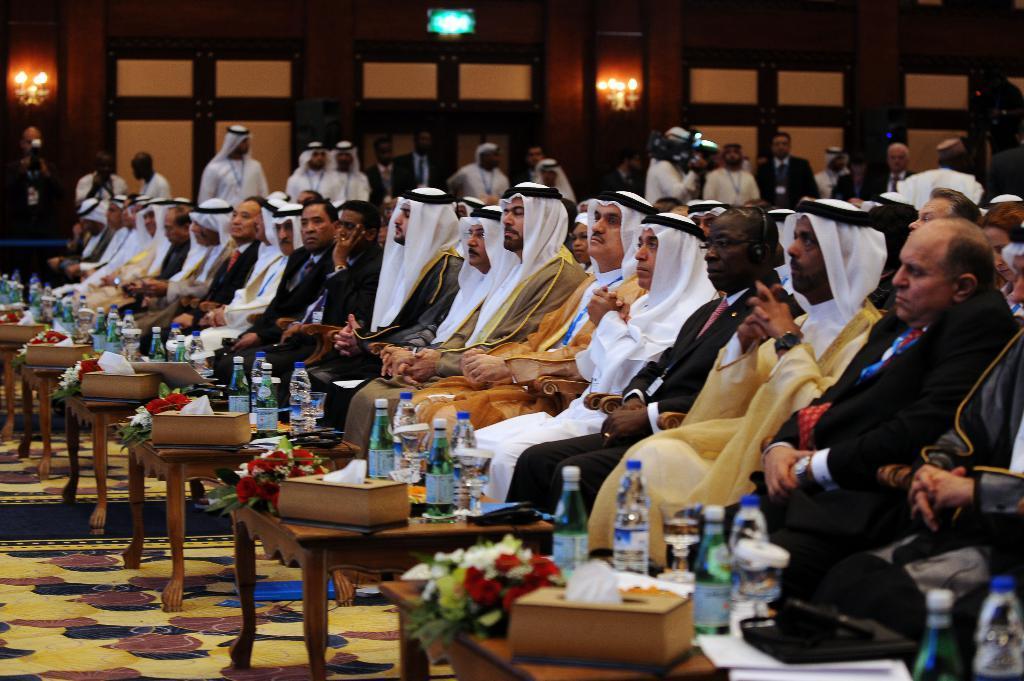Describe this image in one or two sentences. In this image there are group of persons who are sitting in the chairs in front of them there are water bottles,flower bouquet,tissues. 